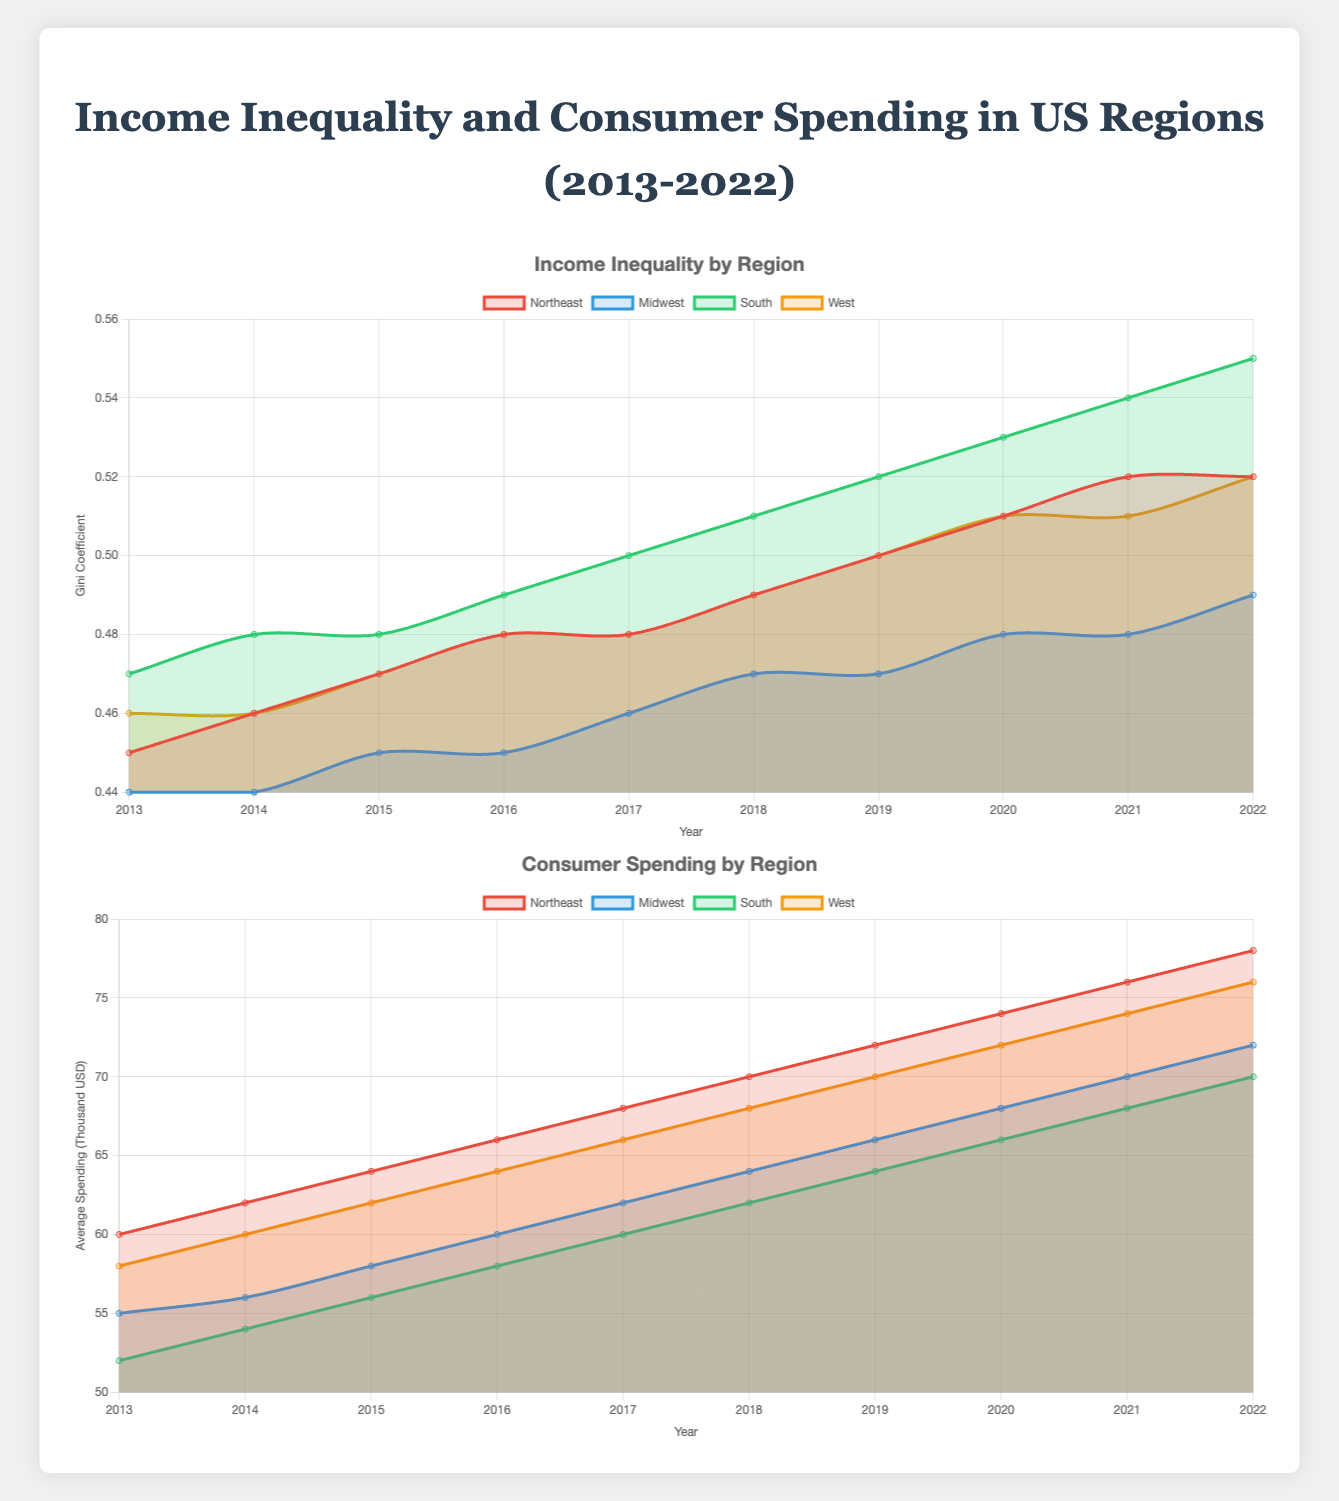How has income inequality in the Northeast changed from 2013 to 2022? Looking at the line plot, the Gini coefficient for the Northeast increased from 0.45 in 2013 to 0.52 in 2022. This shows a steady rise in income inequality over the years.
Answer: Increased from 0.45 to 0.52 Which region had the highest Gini coefficient in 2022 and what was it? The South had the highest Gini coefficient in 2022, with a value of 0.55. This can be seen from the highest point on the line plot for the South in 2022.
Answer: South, 0.55 Compare the consumer spending in the Midwest and South in 2019. Which region had higher spending and by how much? In 2019, consumer spending in the Midwest was 66 (thousand USD) and in the South was 64 (thousand USD). The Midwest had higher spending by 2 thousand USD.
Answer: Midwest, by 2 thousand USD Did any region experience a decline in consumer spending from 2013 to 2022? No region experienced a decline in consumer spending from 2013 to 2022; each region showed a continuous increase over the years. This can be seen as all consumer spending lines trend upwards.
Answer: No What is the difference in income inequality between the South and Northeast in 2017? In 2017, the Gini coefficient for the South was 0.50 and for the Northeast, it was 0.48. The difference is 0.50 - 0.48 = 0.02.
Answer: 0.02 Which region had the smallest change in Gini coefficient over the decade, and what was the change? The Midwest had the smallest change in Gini coefficient, increasing from 0.44 in 2013 to 0.49 in 2022, a change of 0.05.
Answer: Midwest, 0.05 Considering both income inequality and consumer spending, which region appears to have the highest inequality and spending in 2022? In 2022, the South had the highest income inequality (Gini coefficient of 0.55) and the Northeast had the highest consumer spending (78 thousand USD). So, if considering both factors together, the South had the highest inequality, while the Northeast had the highest spending.
Answer: South for inequality, Northeast for spending Does the increase in consumer spending appear to correlate with a rise in income inequality for the regions? For each region, both the consumer spending and Gini coefficient lines trend upwards from 2013 to 2022. This suggests a general positive correlation where regions with rising income inequality also show increased consumer spending.
Answer: Yes, positively correlated On average, by how much did consumer spending increase per year in the West from 2013 to 2022? Consumer spending in the West rose from 58 in 2013 to 76 in 2022. The total increase is 76 - 58 = 18 over 9 years, so the average yearly increase is 18 / 9 = 2.
Answer: 2 per year What was the Gini coefficient in the West in 2016 and 2022, and how much did it increase? The Gini coefficient in the West was 0.48 in 2016 and increased to 0.52 in 2022. The increase was 0.52 - 0.48 = 0.04.
Answer: 0.04 